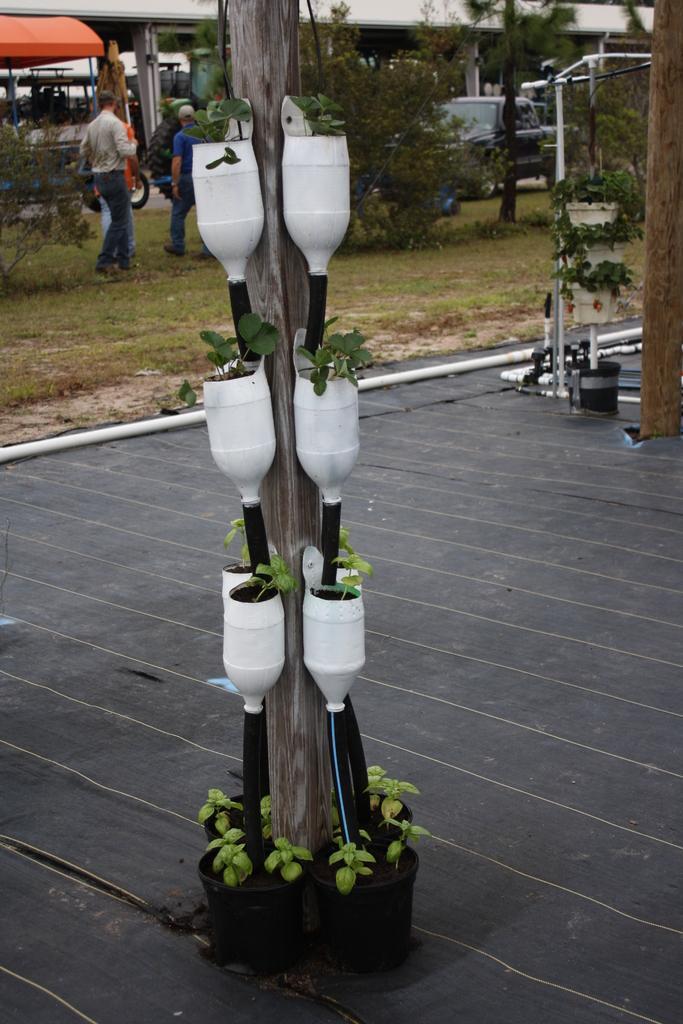Can you describe this image briefly? In this image, we can see plants attached to the pole. There are persons in the top left of the image. There is an another pole in the top right of the image. There are some other plants at the top of the image. 